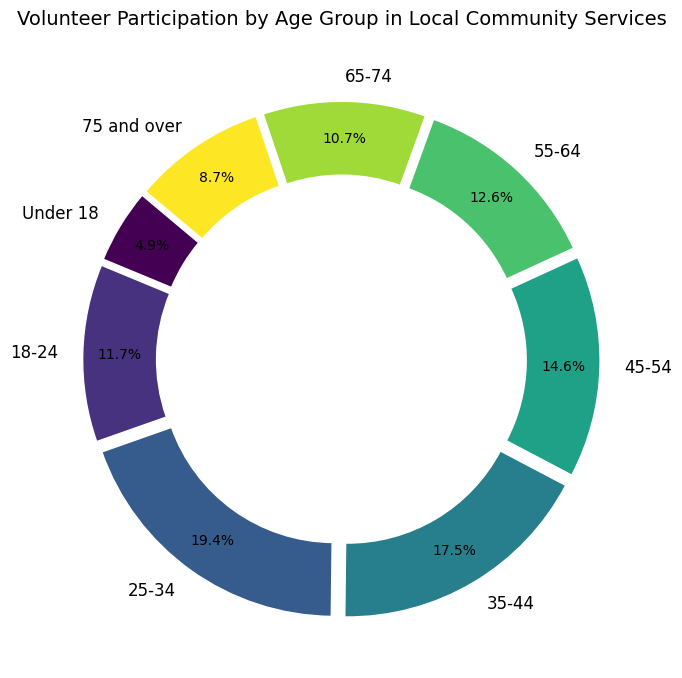What age group has the highest participation in volunteer activities? The wedge corresponding to the 25-34 age group is the largest segment of the ring chart.
Answer: 25-34 Which two age groups have the lowest participation in volunteer activities? The segments corresponding to the 65-74 and 75 and over age groups are the smallest.
Answer: 65-74 and 75 and over What is the total percentage of participation contributed by the 25-34 and 35-44 age groups combined? The 25-34 age group contributes 26.0%, and the 35-44 age group contributes 23.4%. Adding these percentages together results in 26.0% + 23.4% = 49.4%.
Answer: 49.4% Compare the participation of the Under 18 age group to the 18-24 age group in percentage terms. Which group has higher participation? The Under 18 age group has 6.5% participation, whereas the 18-24 age group has 15.6% participation. Therefore, the 18-24 age group has a higher participation rate.
Answer: 18-24 How many age groups have a participation percentage higher than 20%? By examining the wedges, we see that only the 25-34 age group (26.0%) surpasses 20%.
Answer: 1 What age group has a participation percentage closest to 15%? The segment representing the 45-54 age group has a participation percentage of 19.5%, which is closest to 15%.
Answer: 45-54 What are the participation percentages for the 55-64 and 65-74 age groups? The 55-64 age group has a participation percentage of 16.9%, and the 65-74 age group has a participation percentage of 14.3%.
Answer: 16.9% and 14.3% Which age group has participation that is approximately double that of the Under 18 age group? The Under 18 group has a participation of 6.5%. The 18-24 age group has a participation of 15.6%, which is approximately double (13% would be double).
Answer: 18-24 How does the participation percentage of the 35-44 age group compare to the 45-54 age group? The 35-44 age group has a participation percentage of 23.4%, which is higher than the 45-54 age group’s participation percentage of 19.5%.
Answer: 35-44 has higher participation What color is used to represent the 25-34 age group in the chart? The colors in the chart vary based on a specific colormap; the segment for the 25-34 age group is visually notable with a distinct color tone (most likely greenish based on viridis colormap).
Answer: Greenish (according to viridis) 